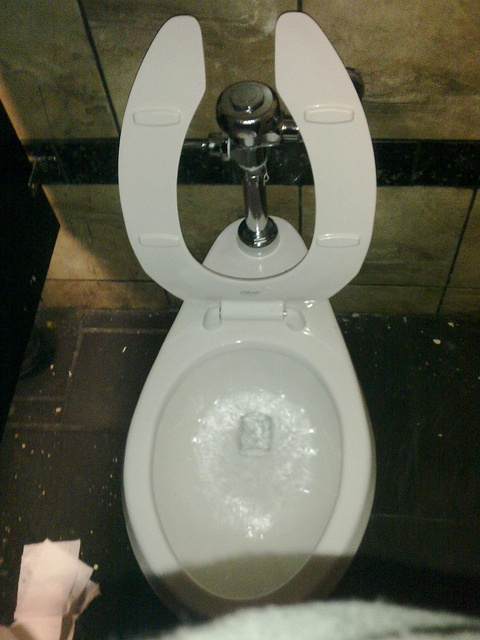Describe the objects in this image and their specific colors. I can see a toilet in black, darkgray, and gray tones in this image. 